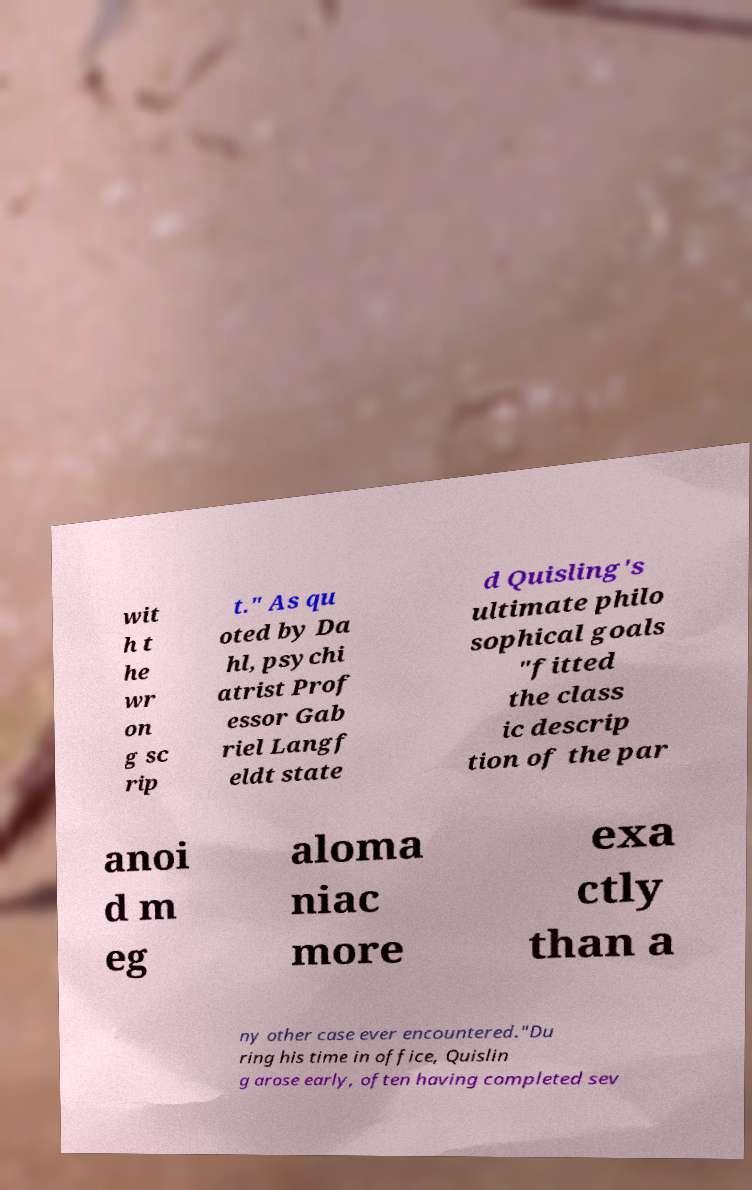Please identify and transcribe the text found in this image. wit h t he wr on g sc rip t." As qu oted by Da hl, psychi atrist Prof essor Gab riel Langf eldt state d Quisling's ultimate philo sophical goals "fitted the class ic descrip tion of the par anoi d m eg aloma niac more exa ctly than a ny other case ever encountered."Du ring his time in office, Quislin g arose early, often having completed sev 